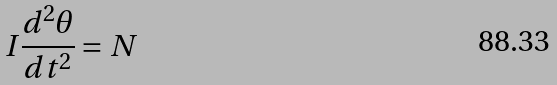<formula> <loc_0><loc_0><loc_500><loc_500>I \frac { d ^ { 2 } \theta } { d t ^ { 2 } } = N</formula> 